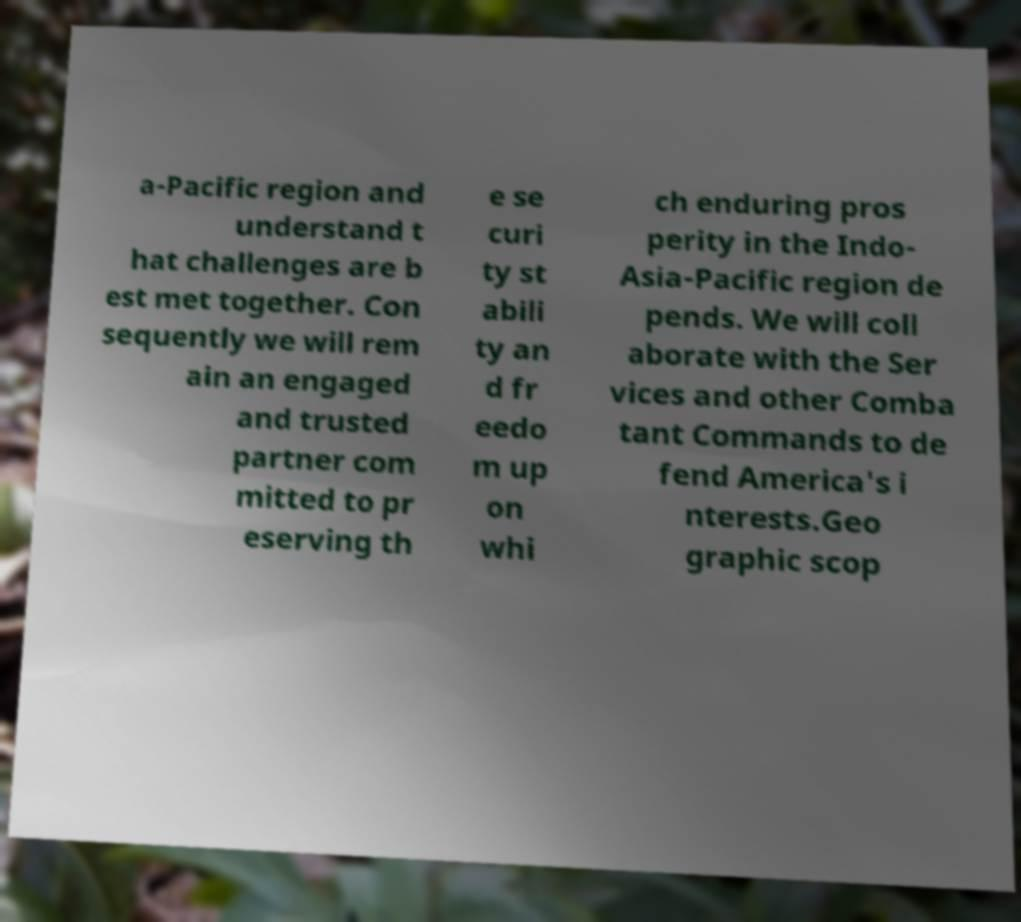Can you read and provide the text displayed in the image?This photo seems to have some interesting text. Can you extract and type it out for me? a-Pacific region and understand t hat challenges are b est met together. Con sequently we will rem ain an engaged and trusted partner com mitted to pr eserving th e se curi ty st abili ty an d fr eedo m up on whi ch enduring pros perity in the Indo- Asia-Pacific region de pends. We will coll aborate with the Ser vices and other Comba tant Commands to de fend America's i nterests.Geo graphic scop 